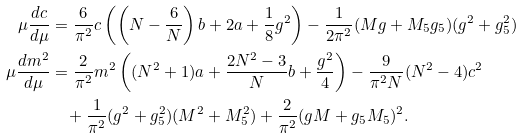<formula> <loc_0><loc_0><loc_500><loc_500>\mu \frac { d c } { d \mu } & = \frac { 6 } { \pi ^ { 2 } } c \left ( \left ( N - \frac { 6 } { N } \right ) b + 2 a + \frac { 1 } { 8 } g ^ { 2 } \right ) - \frac { 1 } { 2 \pi ^ { 2 } } ( M g + M _ { 5 } g _ { 5 } ) ( g ^ { 2 } + g _ { 5 } ^ { 2 } ) \\ \mu \frac { d m ^ { 2 } } { d \mu } & = \frac { 2 } { \pi ^ { 2 } } m ^ { 2 } \left ( ( N ^ { 2 } + 1 ) a + \frac { 2 N ^ { 2 } - 3 } { N } b + \frac { g ^ { 2 } } { 4 } \right ) - \frac { 9 } { \pi ^ { 2 } N } ( N ^ { 2 } - 4 ) c ^ { 2 } \\ & \quad + \frac { 1 } { \pi ^ { 2 } } ( g ^ { 2 } + g _ { 5 } ^ { 2 } ) ( M ^ { 2 } + M _ { 5 } ^ { 2 } ) + \frac { 2 } { \pi ^ { 2 } } ( g M + g _ { 5 } M _ { 5 } ) ^ { 2 } .</formula> 